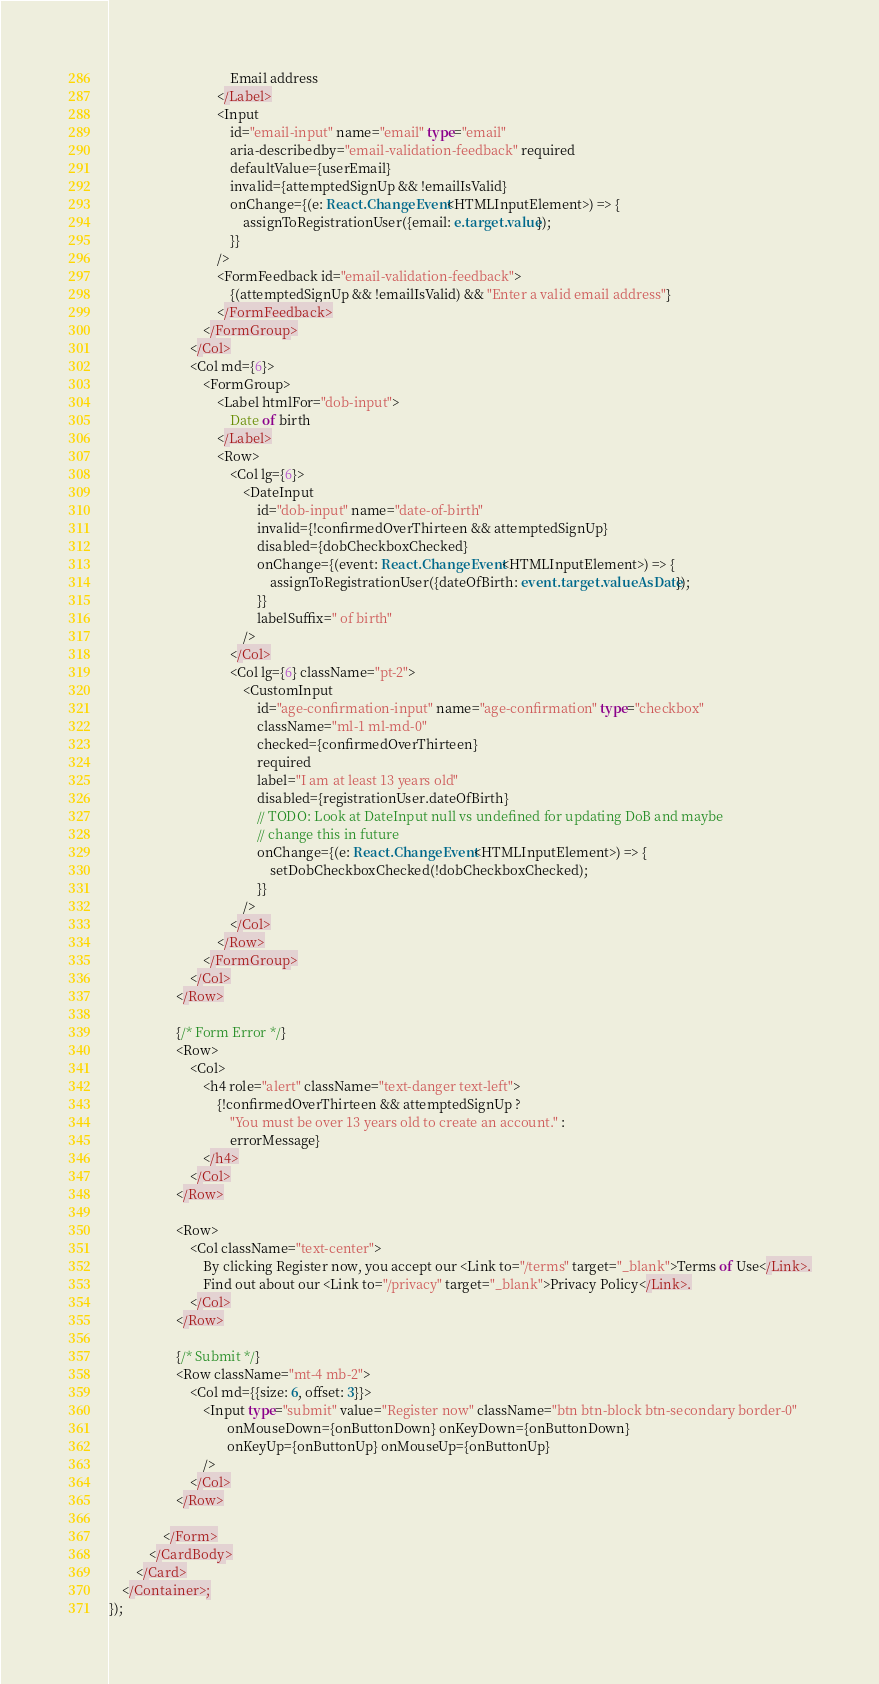<code> <loc_0><loc_0><loc_500><loc_500><_TypeScript_>                                    Email address
                                </Label>
                                <Input
                                    id="email-input" name="email" type="email"
                                    aria-describedby="email-validation-feedback" required
                                    defaultValue={userEmail}
                                    invalid={attemptedSignUp && !emailIsValid}
                                    onChange={(e: React.ChangeEvent<HTMLInputElement>) => {
                                        assignToRegistrationUser({email: e.target.value});
                                    }}
                                />
                                <FormFeedback id="email-validation-feedback">
                                    {(attemptedSignUp && !emailIsValid) && "Enter a valid email address"}
                                </FormFeedback>
                            </FormGroup>
                        </Col>
                        <Col md={6}>
                            <FormGroup>
                                <Label htmlFor="dob-input">
                                    Date of birth
                                </Label>
                                <Row>
                                    <Col lg={6}>
                                        <DateInput
                                            id="dob-input" name="date-of-birth"
                                            invalid={!confirmedOverThirteen && attemptedSignUp}
                                            disabled={dobCheckboxChecked}
                                            onChange={(event: React.ChangeEvent<HTMLInputElement>) => {
                                                assignToRegistrationUser({dateOfBirth: event.target.valueAsDate});
                                            }}
                                            labelSuffix=" of birth"
                                        />
                                    </Col>
                                    <Col lg={6} className="pt-2">
                                        <CustomInput
                                            id="age-confirmation-input" name="age-confirmation" type="checkbox"
                                            className="ml-1 ml-md-0"
                                            checked={confirmedOverThirteen}
                                            required
                                            label="I am at least 13 years old"
                                            disabled={registrationUser.dateOfBirth}
                                            // TODO: Look at DateInput null vs undefined for updating DoB and maybe
                                            // change this in future
                                            onChange={(e: React.ChangeEvent<HTMLInputElement>) => {
                                                setDobCheckboxChecked(!dobCheckboxChecked);
                                            }}
                                        />
                                    </Col>
                                </Row>
                            </FormGroup>
                        </Col>
                    </Row>

                    {/* Form Error */}
                    <Row>
                        <Col>
                            <h4 role="alert" className="text-danger text-left">
                                {!confirmedOverThirteen && attemptedSignUp ?
                                    "You must be over 13 years old to create an account." :
                                    errorMessage}
                            </h4>
                        </Col>
                    </Row>

                    <Row>
                        <Col className="text-center">
                            By clicking Register now, you accept our <Link to="/terms" target="_blank">Terms of Use</Link>.
                            Find out about our <Link to="/privacy" target="_blank">Privacy Policy</Link>.
                        </Col>
                    </Row>

                    {/* Submit */}
                    <Row className="mt-4 mb-2">
                        <Col md={{size: 6, offset: 3}}>
                            <Input type="submit" value="Register now" className="btn btn-block btn-secondary border-0"
                                   onMouseDown={onButtonDown} onKeyDown={onButtonDown}
                                   onKeyUp={onButtonUp} onMouseUp={onButtonUp}
                            />
                        </Col>
                    </Row>

                </Form>
            </CardBody>
        </Card>
    </Container>;
});
</code> 